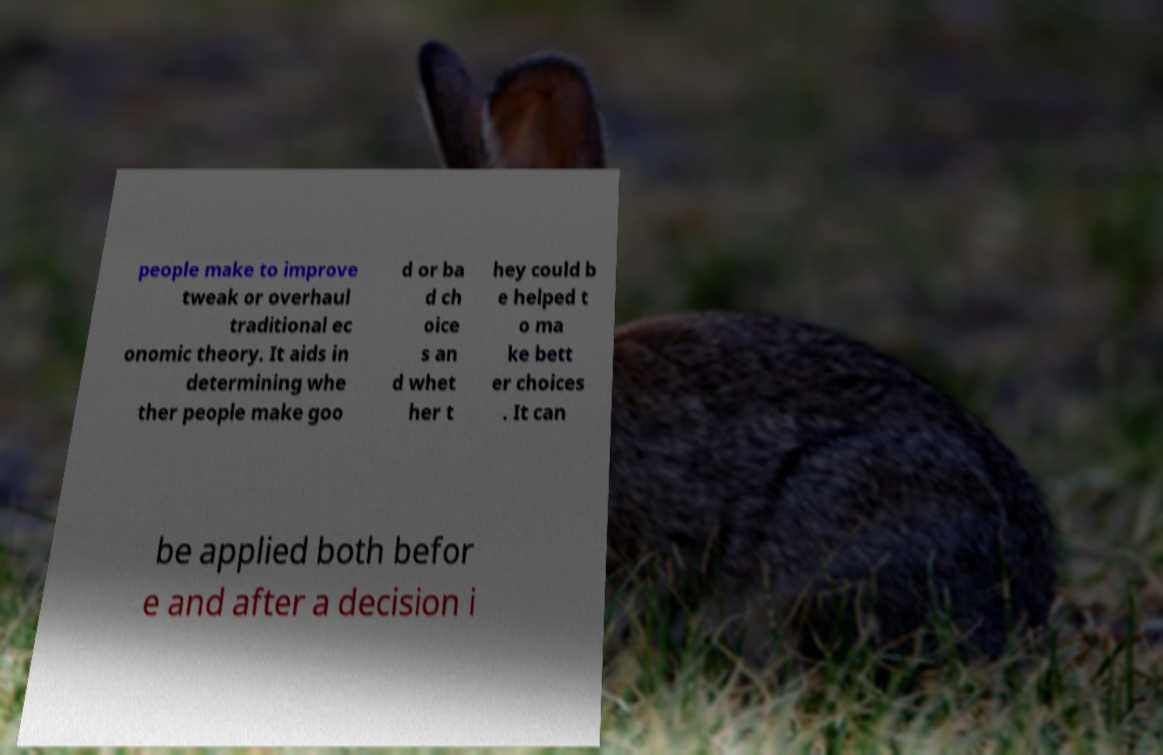I need the written content from this picture converted into text. Can you do that? people make to improve tweak or overhaul traditional ec onomic theory. It aids in determining whe ther people make goo d or ba d ch oice s an d whet her t hey could b e helped t o ma ke bett er choices . It can be applied both befor e and after a decision i 